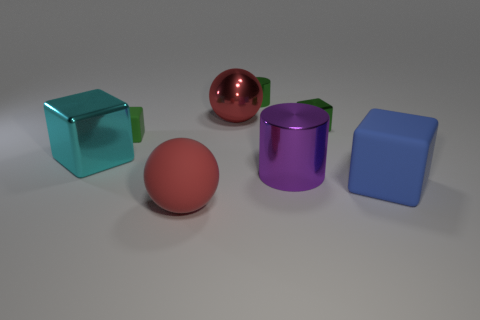Add 1 red spheres. How many objects exist? 9 Subtract all blue cubes. How many cubes are left? 3 Subtract all cylinders. How many objects are left? 6 Subtract 1 blocks. How many blocks are left? 3 Subtract all green blocks. Subtract all purple spheres. How many blocks are left? 2 Subtract all green cubes. How many purple cylinders are left? 1 Add 1 large balls. How many large balls are left? 3 Add 7 red balls. How many red balls exist? 9 Subtract 1 green cylinders. How many objects are left? 7 Subtract all red cubes. Subtract all large cyan cubes. How many objects are left? 7 